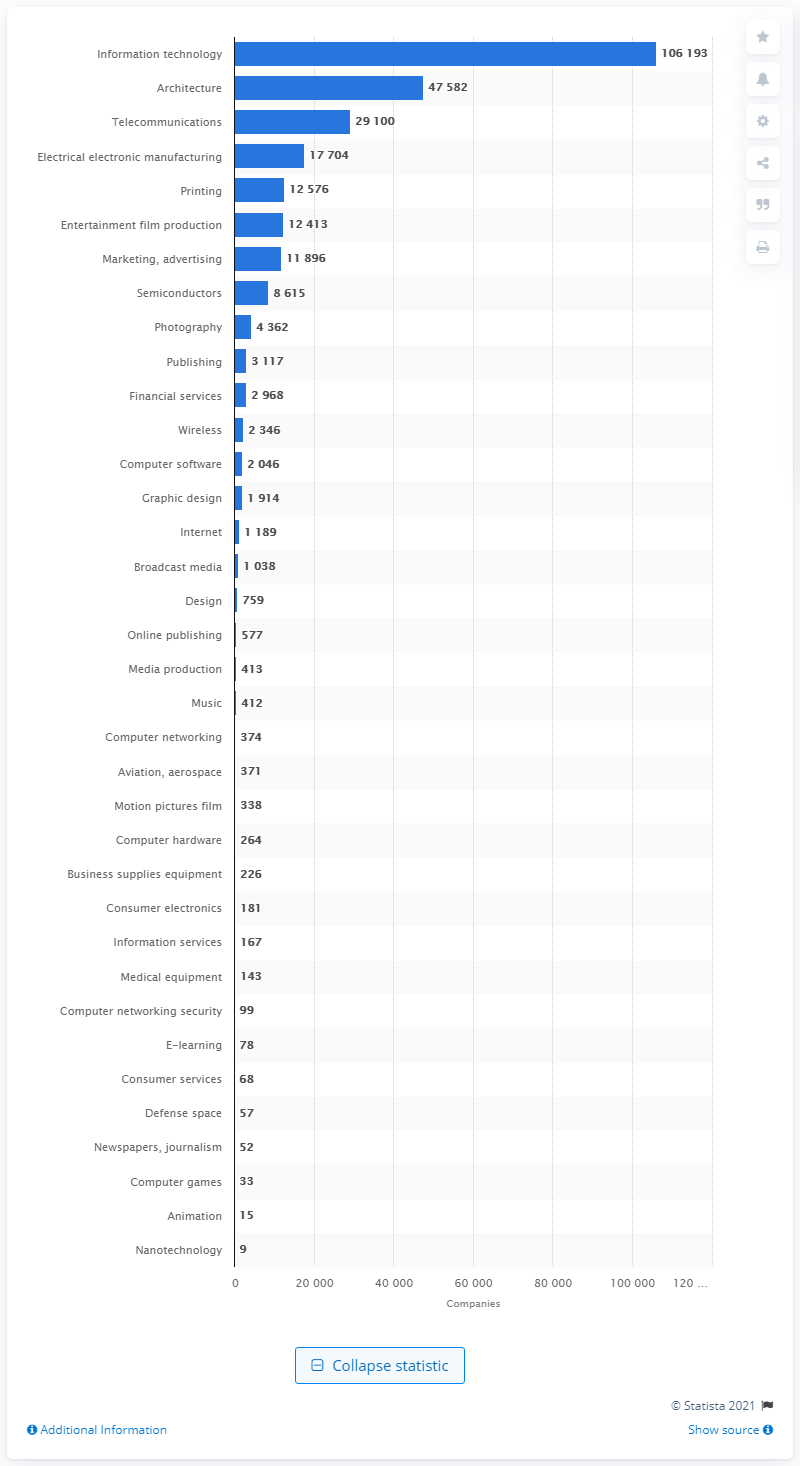Indicate a few pertinent items in this graphic. In 2012, there were 11,896 printing companies in the United Kingdom. 